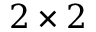Convert formula to latex. <formula><loc_0><loc_0><loc_500><loc_500>2 \times 2</formula> 